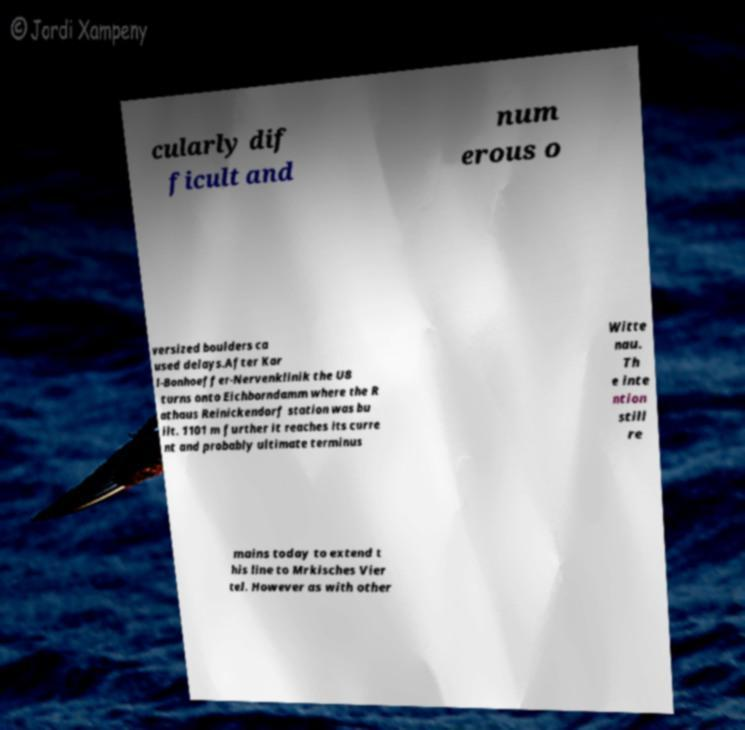Please identify and transcribe the text found in this image. cularly dif ficult and num erous o versized boulders ca used delays.After Kar l-Bonhoeffer-Nervenklinik the U8 turns onto Eichborndamm where the R athaus Reinickendorf station was bu ilt. 1101 m further it reaches its curre nt and probably ultimate terminus Witte nau. Th e inte ntion still re mains today to extend t his line to Mrkisches Vier tel. However as with other 